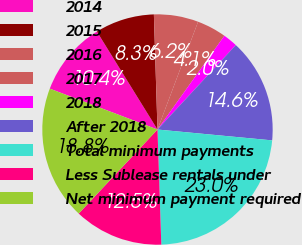Convert chart to OTSL. <chart><loc_0><loc_0><loc_500><loc_500><pie_chart><fcel>2014<fcel>2015<fcel>2016<fcel>2017<fcel>2018<fcel>After 2018<fcel>Total minimum payments<fcel>Less Sublease rentals under<fcel>Net minimum payment required<nl><fcel>10.41%<fcel>8.32%<fcel>6.23%<fcel>4.13%<fcel>2.04%<fcel>14.6%<fcel>22.97%<fcel>12.51%<fcel>18.79%<nl></chart> 